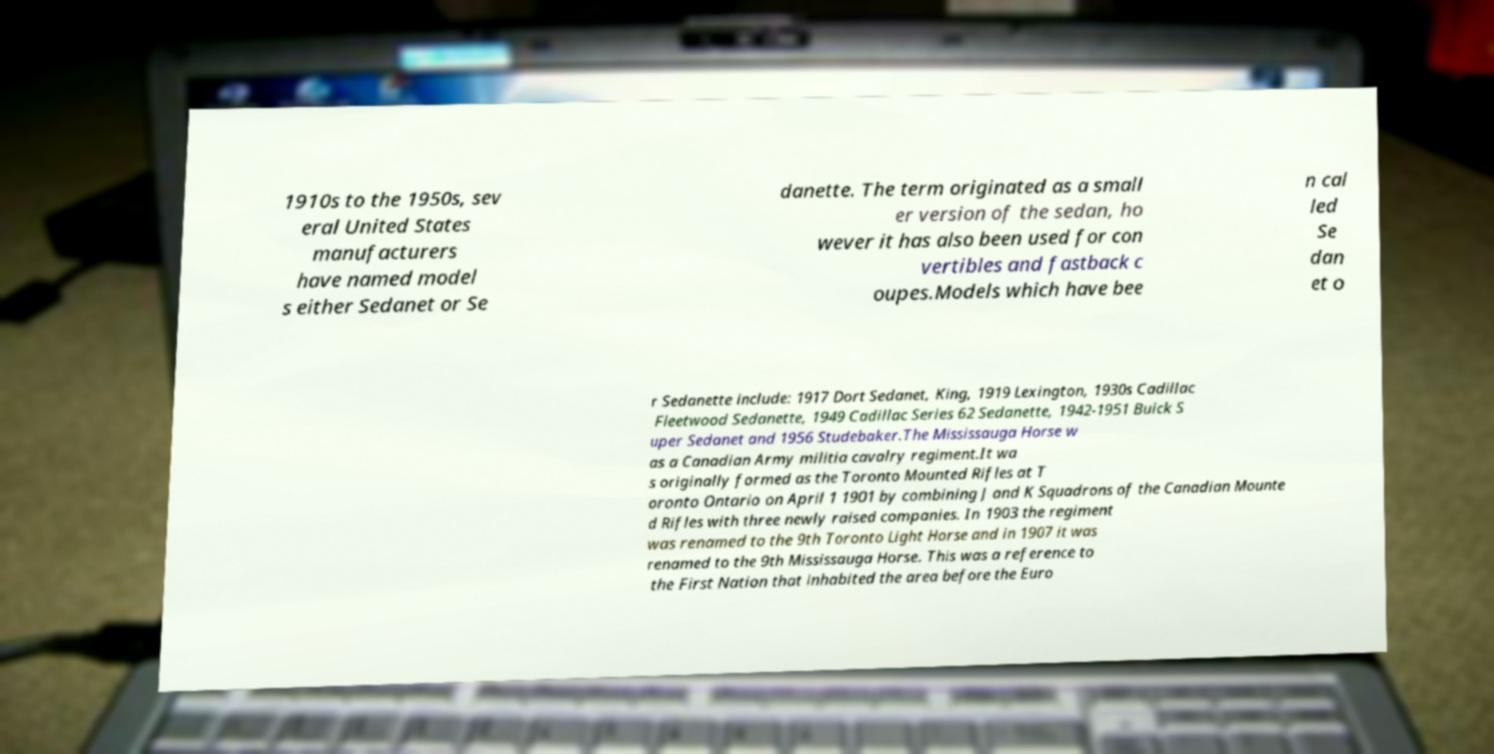Can you accurately transcribe the text from the provided image for me? 1910s to the 1950s, sev eral United States manufacturers have named model s either Sedanet or Se danette. The term originated as a small er version of the sedan, ho wever it has also been used for con vertibles and fastback c oupes.Models which have bee n cal led Se dan et o r Sedanette include: 1917 Dort Sedanet, King, 1919 Lexington, 1930s Cadillac Fleetwood Sedanette, 1949 Cadillac Series 62 Sedanette, 1942-1951 Buick S uper Sedanet and 1956 Studebaker.The Mississauga Horse w as a Canadian Army militia cavalry regiment.It wa s originally formed as the Toronto Mounted Rifles at T oronto Ontario on April 1 1901 by combining J and K Squadrons of the Canadian Mounte d Rifles with three newly raised companies. In 1903 the regiment was renamed to the 9th Toronto Light Horse and in 1907 it was renamed to the 9th Mississauga Horse. This was a reference to the First Nation that inhabited the area before the Euro 